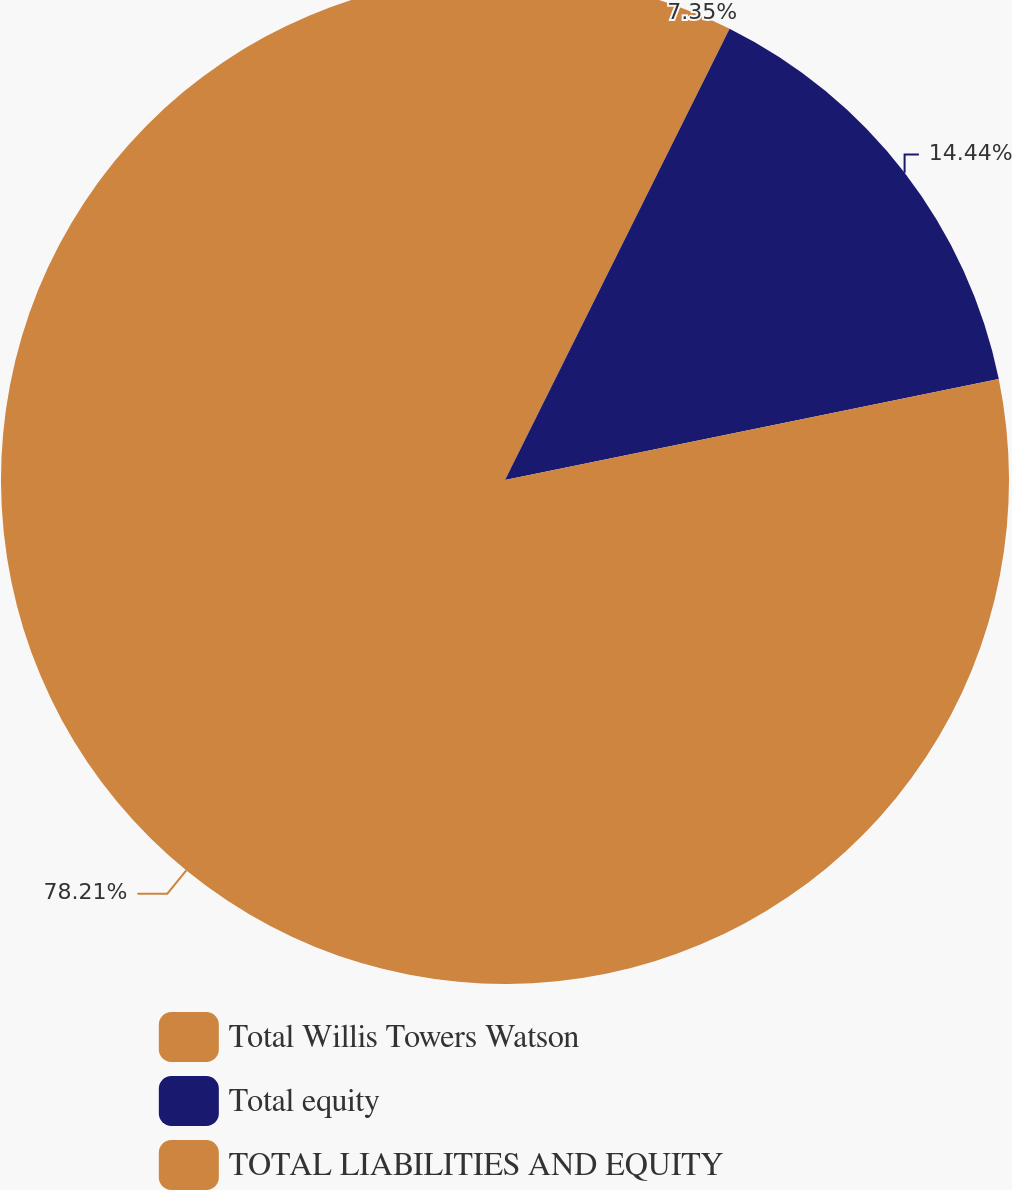Convert chart. <chart><loc_0><loc_0><loc_500><loc_500><pie_chart><fcel>Total Willis Towers Watson<fcel>Total equity<fcel>TOTAL LIABILITIES AND EQUITY<nl><fcel>7.35%<fcel>14.44%<fcel>78.21%<nl></chart> 